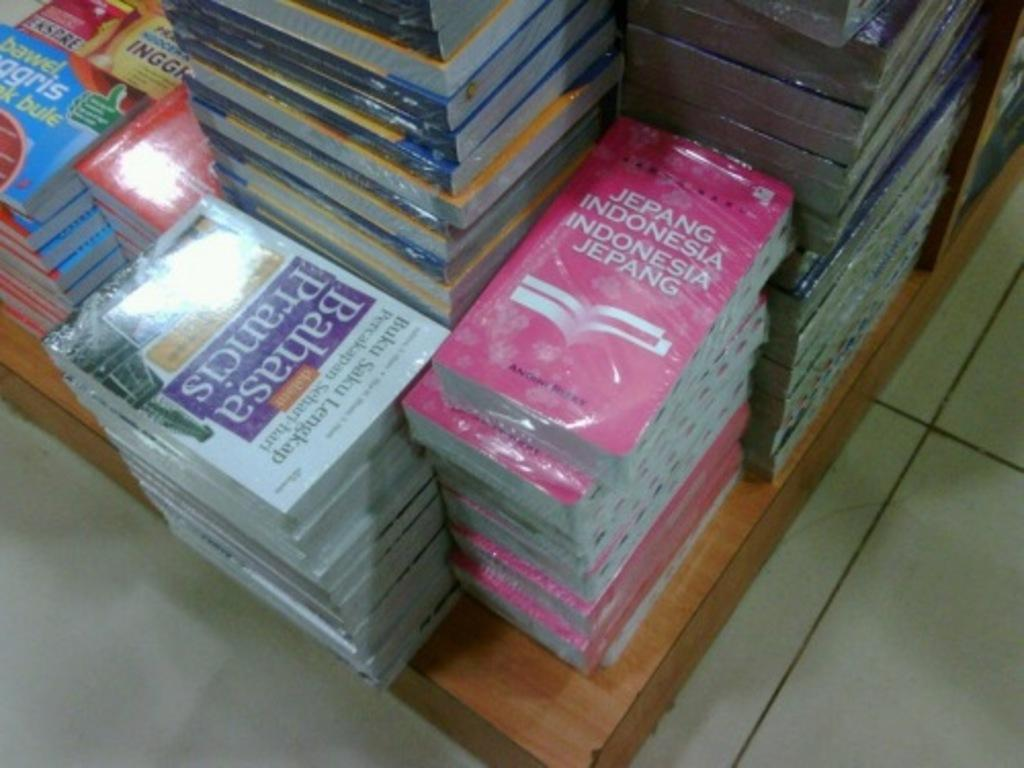<image>
Offer a succinct explanation of the picture presented. many books are stacked on a wooden platform, including one called Bahasa  Prancis 